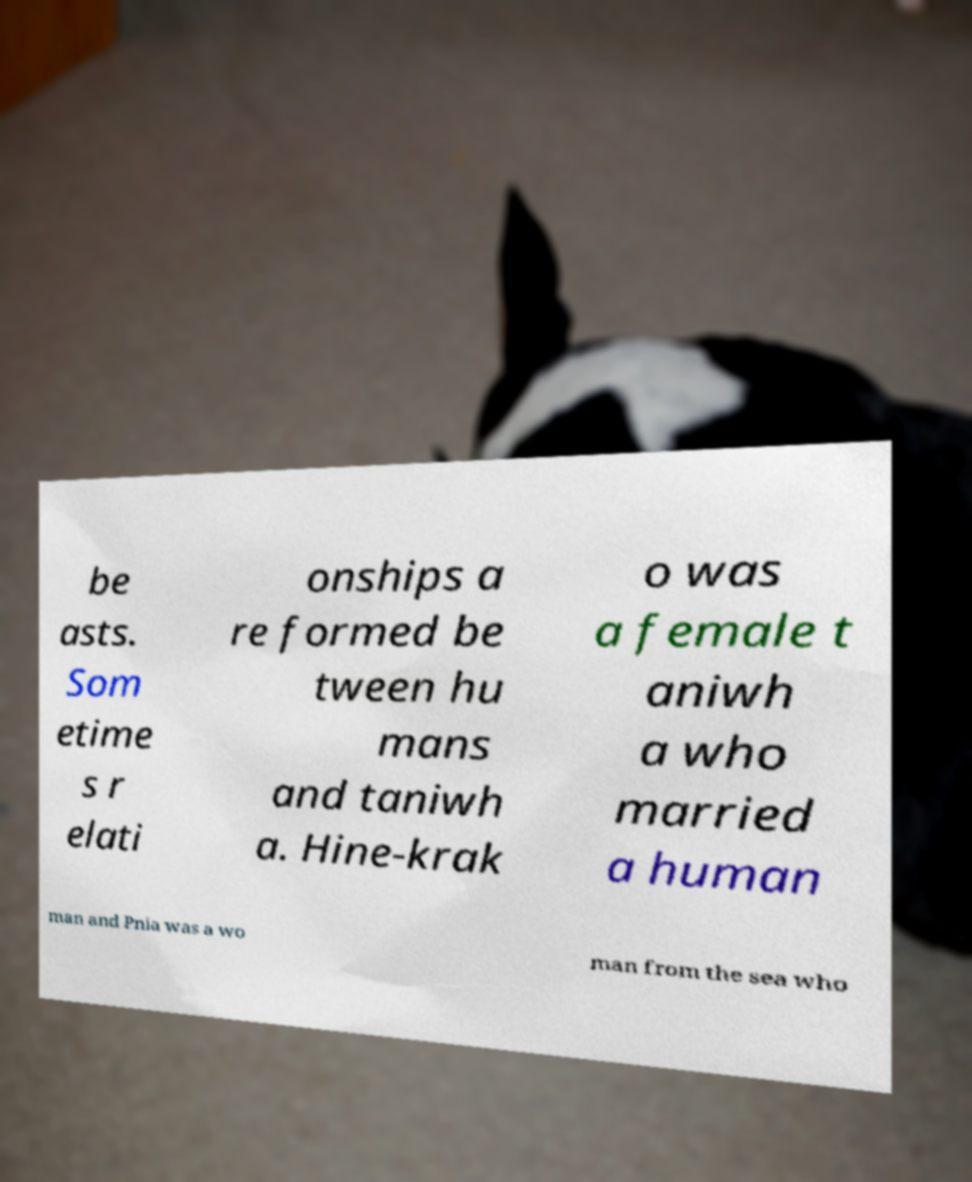For documentation purposes, I need the text within this image transcribed. Could you provide that? be asts. Som etime s r elati onships a re formed be tween hu mans and taniwh a. Hine-krak o was a female t aniwh a who married a human man and Pnia was a wo man from the sea who 